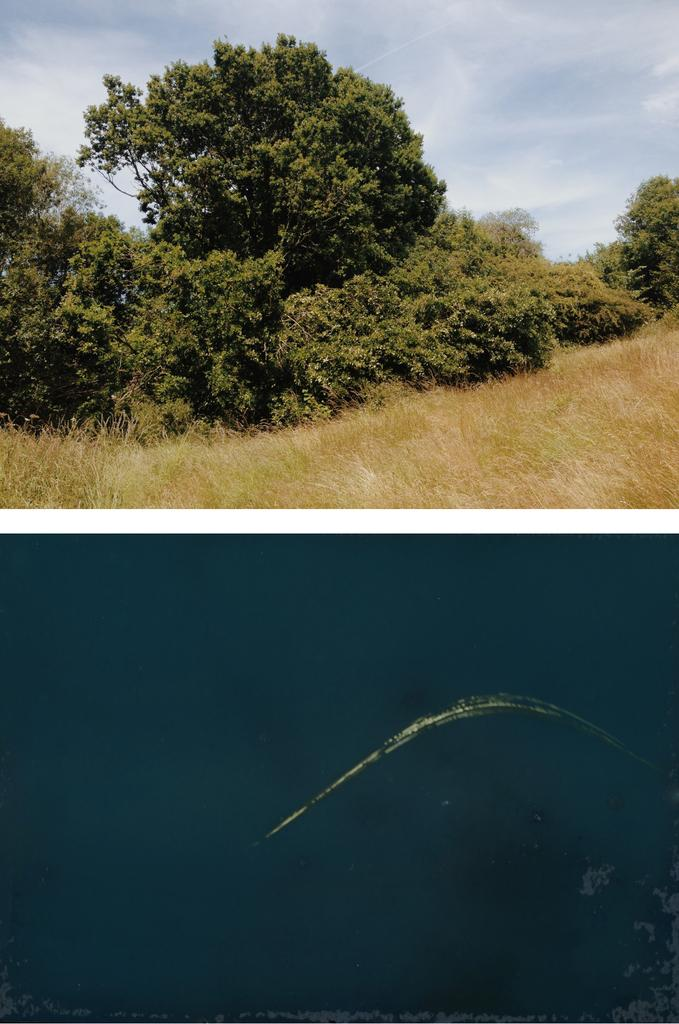What type of artwork is the image? The image is a collage. What type of vegetation can be seen in the image? There are trees in the image. What is on the ground in the image? There is grass on the ground in the image. What is visible in the sky in the image? There is smoke visible in the sky in the image. What type of hat is the tree wearing in the image? There are no hats present in the image, as trees do not wear hats. 